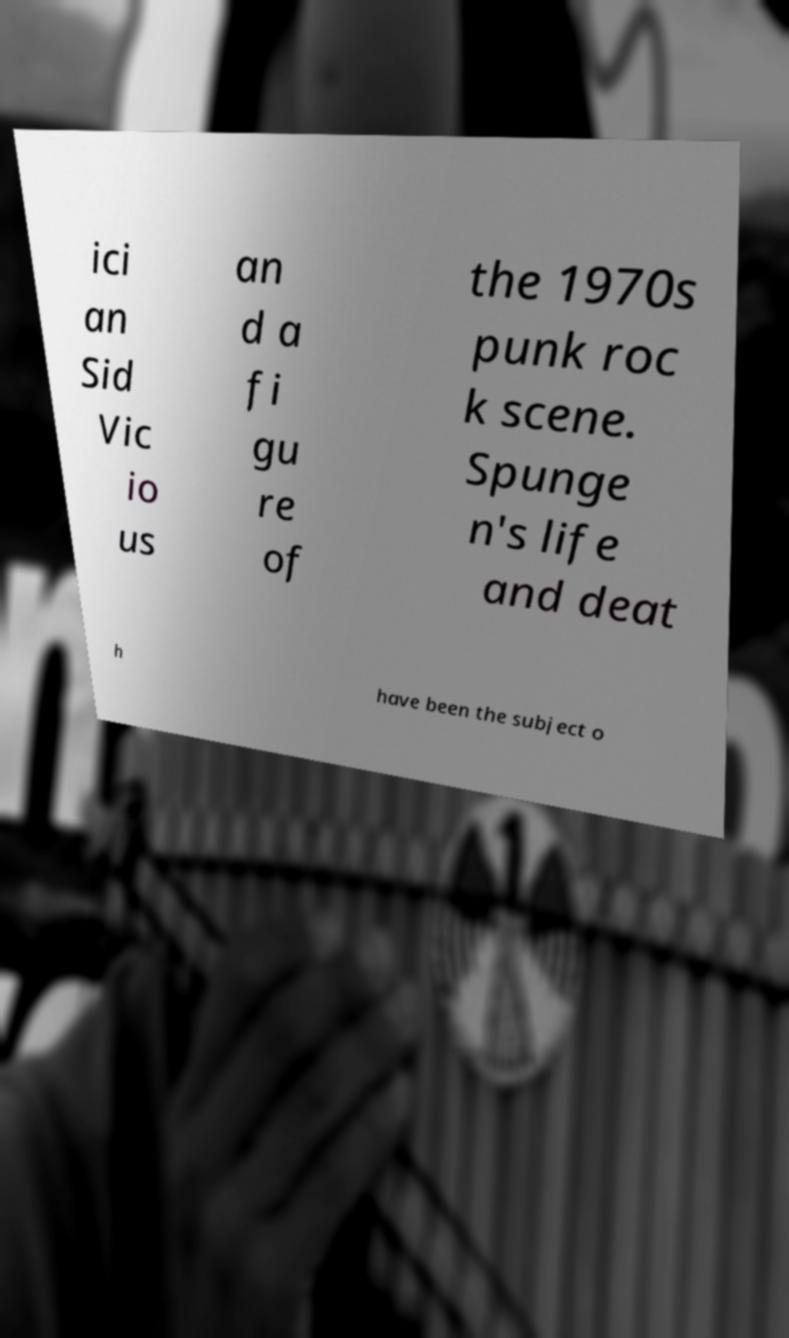Could you extract and type out the text from this image? ici an Sid Vic io us an d a fi gu re of the 1970s punk roc k scene. Spunge n's life and deat h have been the subject o 